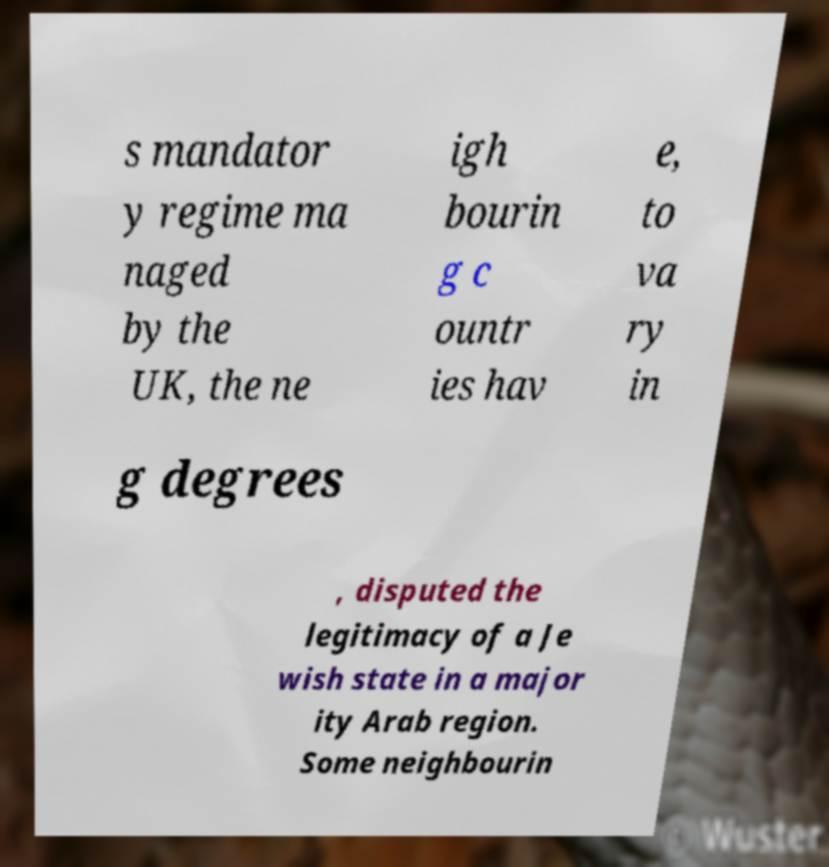Could you extract and type out the text from this image? s mandator y regime ma naged by the UK, the ne igh bourin g c ountr ies hav e, to va ry in g degrees , disputed the legitimacy of a Je wish state in a major ity Arab region. Some neighbourin 